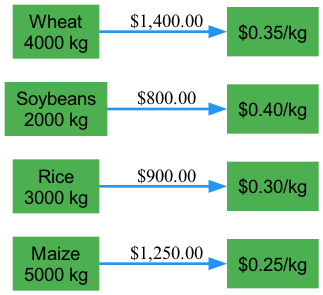What is the total quantity of Maize cultivated? The node for Maize shows a quantity of 5000 kg indicated by the text in the box.
Answer: 5000 kg What is the price per kg for Soybeans? The node for Soybeans shows the price of $0.40/kg. This price is indicated directly next to the Soybeans price node.
Answer: $0.40/kg How many crops were cultivated in the Kharif season? The diagram includes only one crop cultivated during the Kharif season, which is Rice. This is confirmed by checking the season links.
Answer: 1 What is the total earnings from Wheat cultivated in the Rabi season? The quantity of Wheat is 4000 kg and the price per kg is $0.35. Therefore, 4000 kg * $0.35/kg = $1400. This calculation follows the flow from the Wheat node to the price node.
Answer: $1400 Which crop has the highest market price per kg? By comparing the market prices shown next to each crop, Soybeans has the highest price at $0.40/kg. The comparison involves checking all the price nodes for each crop.
Answer: Soybeans What is the total flow value from Rice to its market price? The flow is represented as the total earnings from Rice, which is calculated as 3000 kg * $0.30/kg = $900, indicating the flow from the Rice node to the price node.
Answer: $900 How many edges are there in total from cultivated crops to market prices? Four crops have been depicted, and each one connects to its respective market price with one edge, resulting in a total of four edges in the diagram.
Answer: 4 Which season has the highest quantity of crops cultivated? By comparing the quantities of crops, the Summer season has a total of 7000 kg (5000 kg of Maize and 2000 kg of Soybeans), which is higher than any other season.
Answer: Summer What is the total quantity of crops cultivated in the Summer season? Maize (5000 kg) and Soybeans (2000 kg) are both cultivated in the Summer. Adding these together gives 5000 kg + 2000 kg = 7000 kg, which can be seen in the flows from both crop nodes.
Answer: 7000 kg 